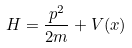<formula> <loc_0><loc_0><loc_500><loc_500>H = \frac { p ^ { 2 } } { 2 m } + V ( x )</formula> 